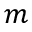<formula> <loc_0><loc_0><loc_500><loc_500>m</formula> 